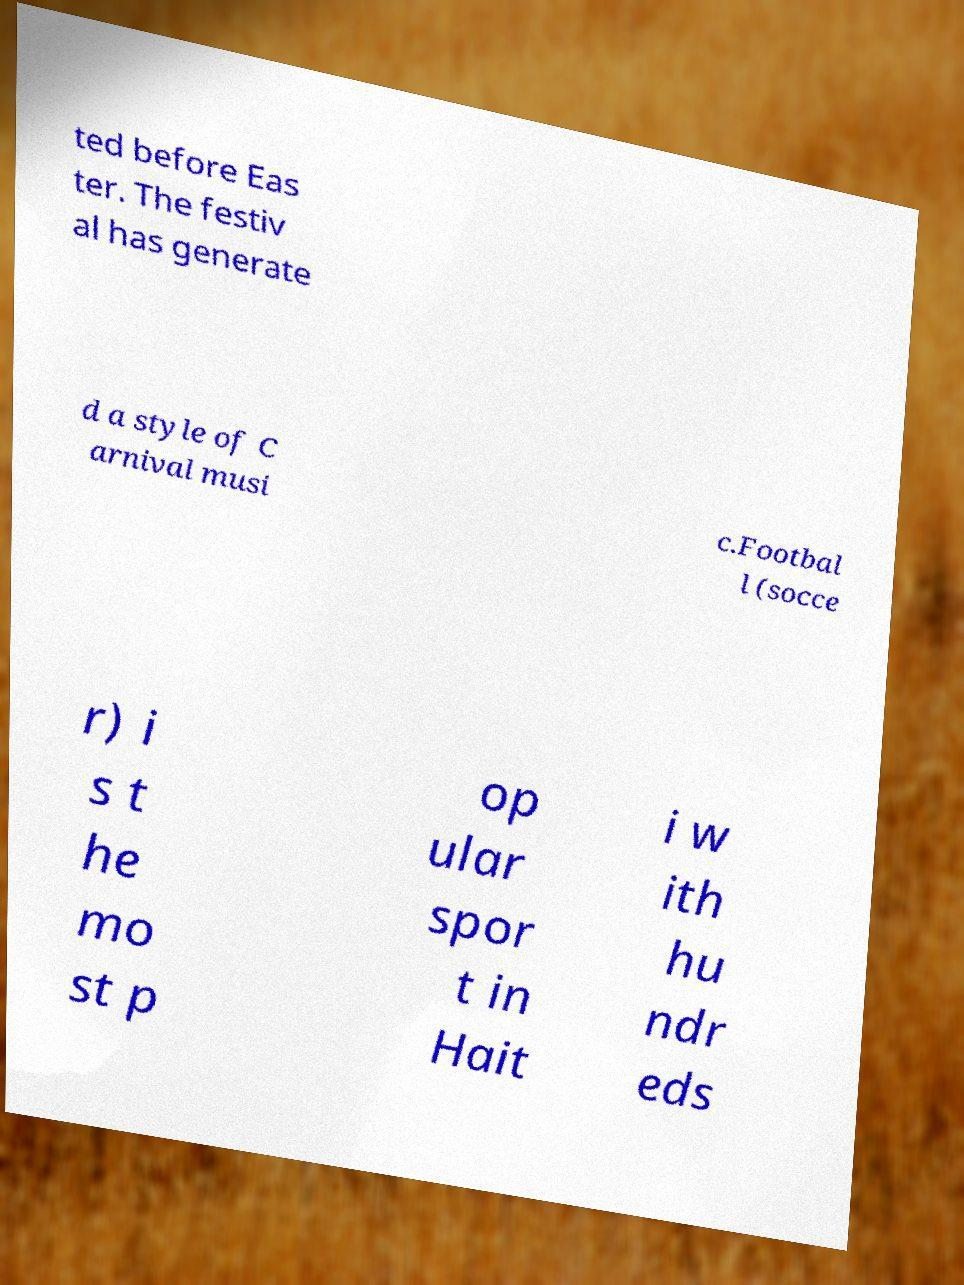Please identify and transcribe the text found in this image. ted before Eas ter. The festiv al has generate d a style of C arnival musi c.Footbal l (socce r) i s t he mo st p op ular spor t in Hait i w ith hu ndr eds 